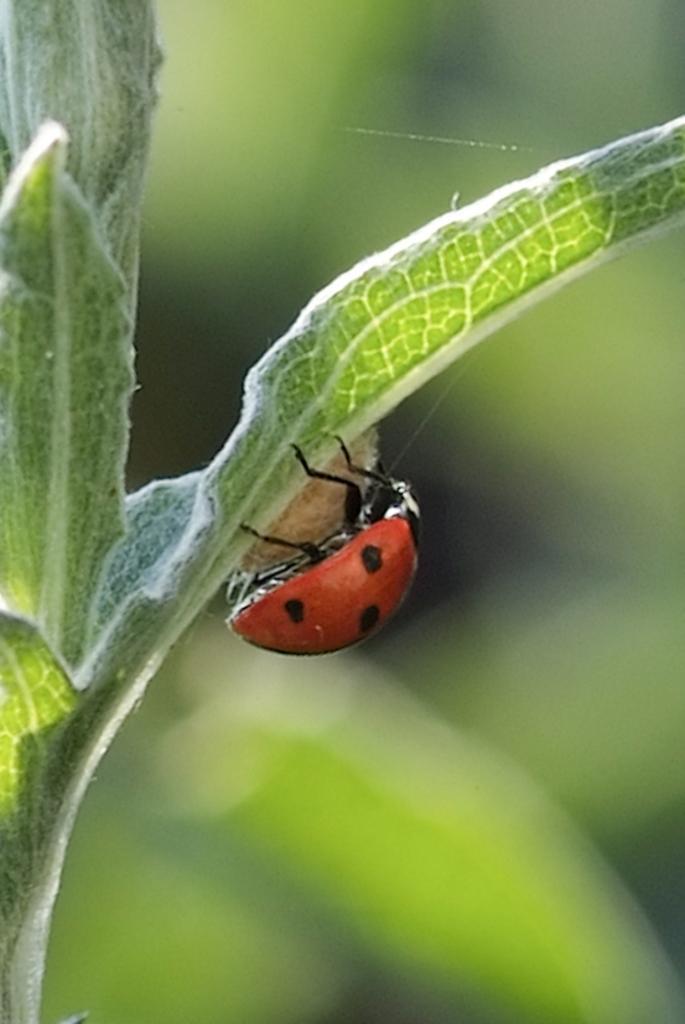Please provide a concise description of this image. In this image I can see few green color leaves and on it I can see a bug. I can also see this image is blurry in the background. 